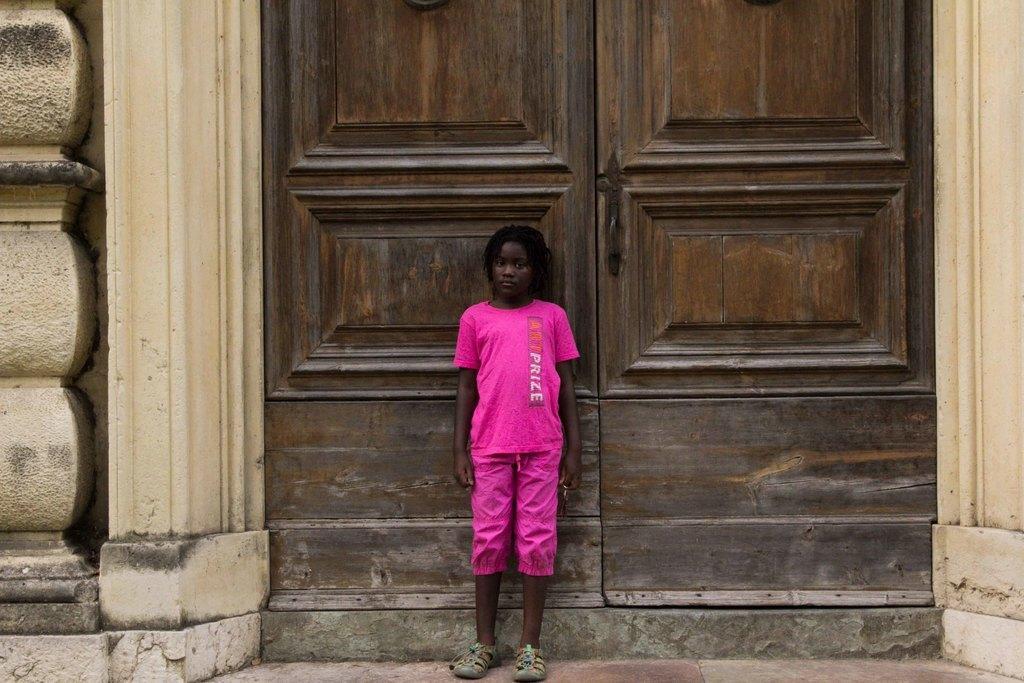How would you summarize this image in a sentence or two? In this picture we can see a person is standing, in the background there is double door, this person wore footwear and pink color clothes. 